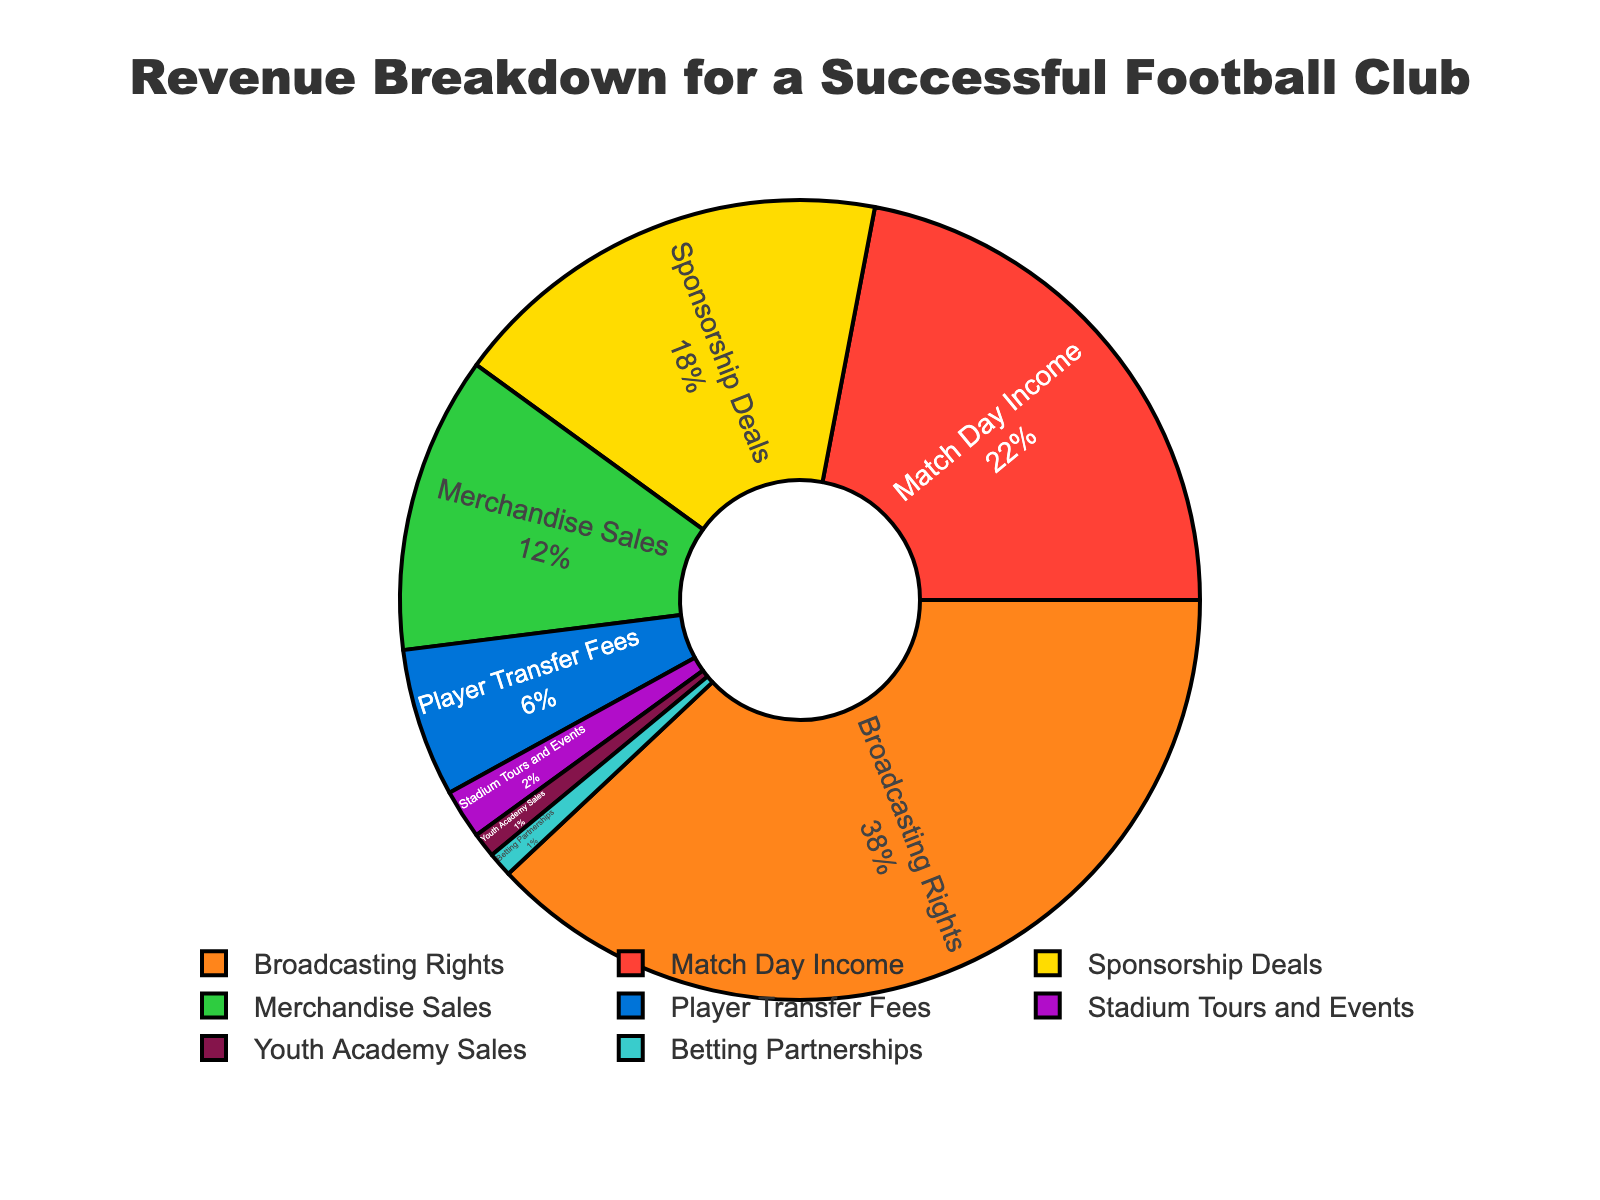Which revenue source contributes the highest percentage? The largest slice in the pie chart represents Broadcasting Rights with a 38% contribution.
Answer: Broadcasting Rights What is the combined percentage of Match Day Income and Sponsorship Deals? Match Day Income is 22% and Sponsorship Deals are 18%. Their combined percentage is 22% + 18% = 40%.
Answer: 40% Which revenue source has the smallest contribution, and what is its percentage? The smallest slices in the pie chart each represent Youth Academy Sales and Betting Partnerships, both contributing 1%.
Answer: Youth Academy Sales and Betting Partnerships, 1% How does the percentage of Merchandise Sales compare to Player Transfer Fees? Merchandise Sales is 12%, whereas Player Transfer Fees is 6%. Merchandise Sales is twice as much as Player Transfer Fees.
Answer: Merchandise Sales is twice Player Transfer Fees What is the percentage difference between the revenue from Broadcasting Rights and Match Day Income? Broadcasting Rights contribute 38% and Match Day Income 22%. The difference is 38% - 22% = 16%.
Answer: 16% Among Sponsorship Deals, Merchandise Sales, and Stadium Tours and Events, which has the highest percentage, and which has the lowest? Sponsorship Deals have the highest at 18%, and Stadium Tours and Events have the lowest at 2%.
Answer: Sponsorship Deals, Stadium Tours and Events What is the total percentage of revenue provided by sources other than Broadcasting Rights and Match Day Income? All other sources combined are Sponsorship Deals (18%), Merchandise Sales (12%), Player Transfer Fees (6%), Stadium Tours and Events (2%), Youth Academy Sales (1%), and Betting Partnerships (1%). Their total is 18% + 12% + 6% + 2% + 1% + 1% = 40%.
Answer: 40% If the revenue from Broadcasting Rights were reduced by half, what would be its new percentage? Broadcasting Rights currently contribute 38%. Halving this would give 38% / 2 = 19%.
Answer: 19% What percentage does Sponsorship Deals contribute relative to the total percentage of Player Transfer Fees and Match Day Income combined? Match Day Income is 22% and Player Transfer Fees are 6%, combining them gives 22% + 6% = 28%. Sponsorship Deals contribute 18%, which is 18% / 28% = 64.3% of the combined percentage of Player Transfer Fees and Match Day Income.
Answer: 64.3% 